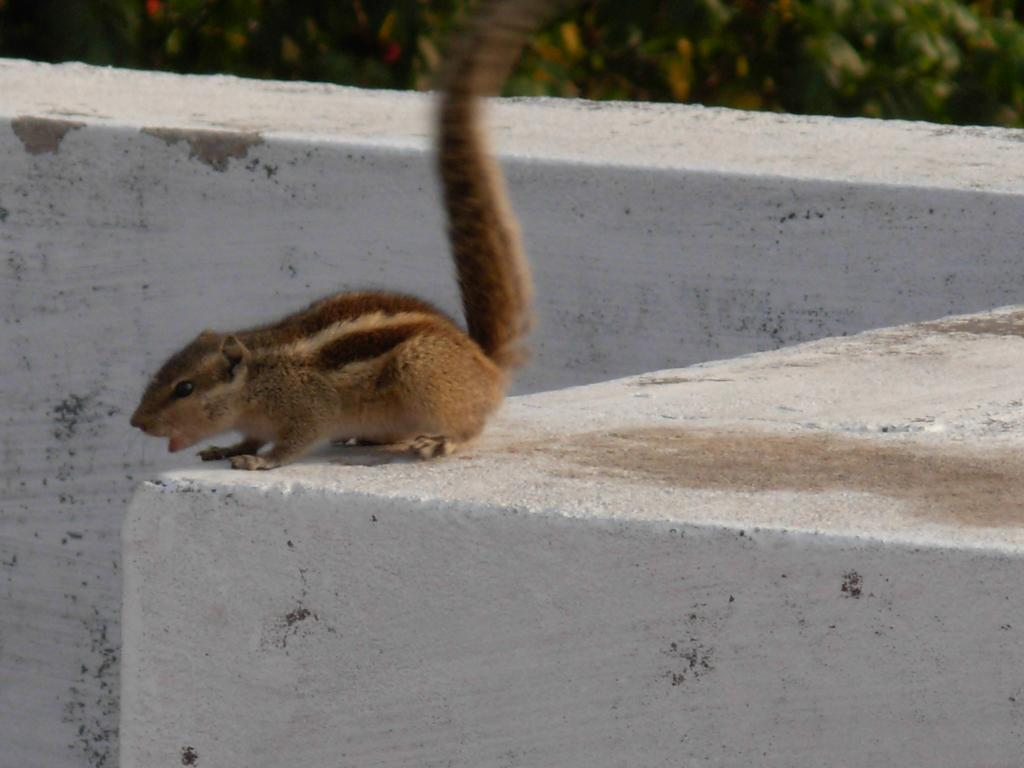What type of animal is in the image? There is a squirrel in the image. Where is the squirrel located? The squirrel is on a wall. How does the squirrel help reduce pollution in the image? The image does not show the squirrel doing anything related to pollution, and squirrels do not have a direct impact on pollution levels. 